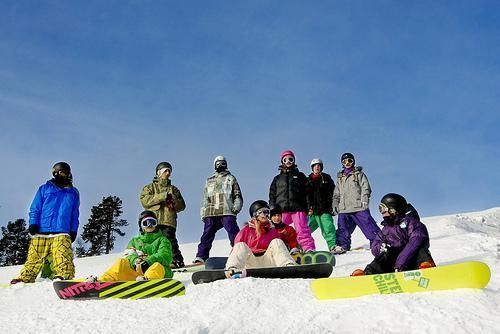How many people are there?
Give a very brief answer. 9. How many men have yellow pants?
Give a very brief answer. 1. 